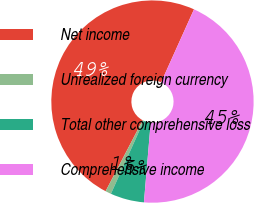<chart> <loc_0><loc_0><loc_500><loc_500><pie_chart><fcel>Net income<fcel>Unrealized foreign currency<fcel>Total other comprehensive loss<fcel>Comprehensive income<nl><fcel>49.07%<fcel>0.93%<fcel>5.39%<fcel>44.61%<nl></chart> 